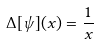<formula> <loc_0><loc_0><loc_500><loc_500>\Delta [ \psi ] ( x ) = \frac { 1 } { x }</formula> 